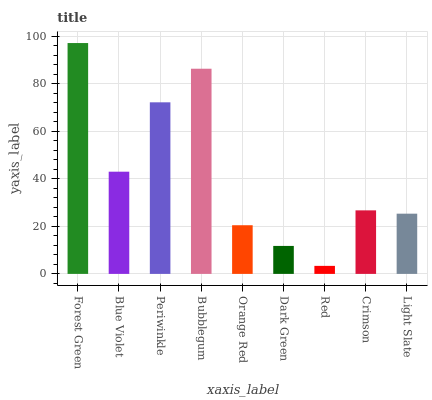Is Red the minimum?
Answer yes or no. Yes. Is Forest Green the maximum?
Answer yes or no. Yes. Is Blue Violet the minimum?
Answer yes or no. No. Is Blue Violet the maximum?
Answer yes or no. No. Is Forest Green greater than Blue Violet?
Answer yes or no. Yes. Is Blue Violet less than Forest Green?
Answer yes or no. Yes. Is Blue Violet greater than Forest Green?
Answer yes or no. No. Is Forest Green less than Blue Violet?
Answer yes or no. No. Is Crimson the high median?
Answer yes or no. Yes. Is Crimson the low median?
Answer yes or no. Yes. Is Blue Violet the high median?
Answer yes or no. No. Is Blue Violet the low median?
Answer yes or no. No. 